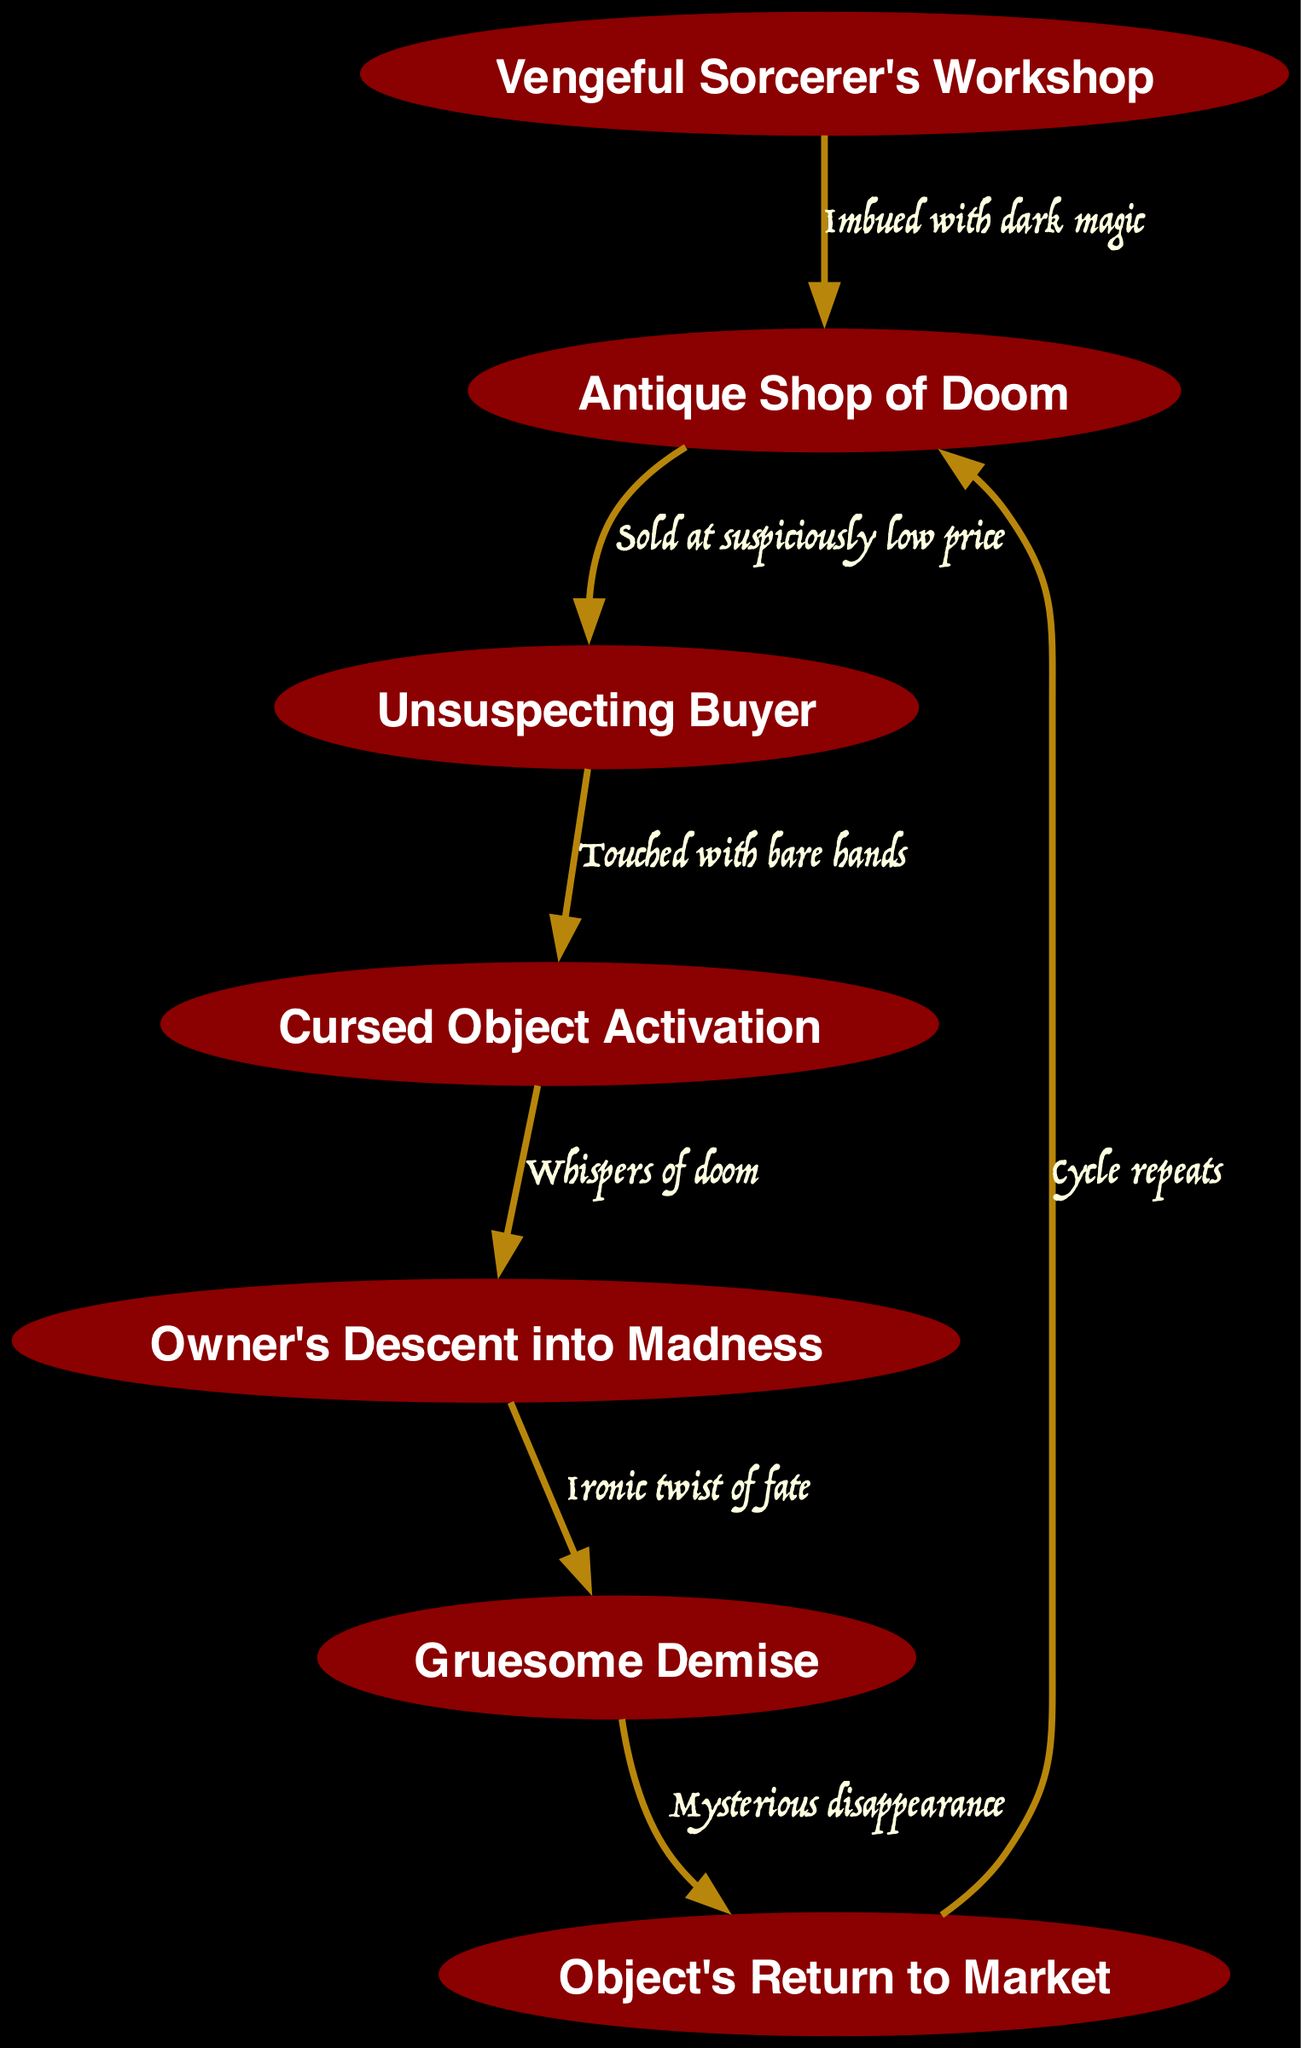What is the first node in the diagram? The first node listed in the data is "Vengeful Sorcerer's Workshop". This represents the origin of the cursed object, indicating where dark magic is applied prior to entering the market.
Answer: Vengeful Sorcerer's Workshop How many nodes are in the diagram? The diagram comprises a total of seven nodes, each representing a distinct stage in the life cycle of the cursed object, from its creation to its resale.
Answer: 7 What edge connects the Antique Shop of Doom to the Unsuspecting Buyer? The edge connecting these two nodes is labeled "Sold at suspiciously low price". This indicates that the cursed object is sold at a price that raises suspicion.
Answer: Sold at suspiciously low price What happens when the owner touches the cursed object? Upon touching the object, it activates, initiating a series of ominous effects as indicated by the edge label "Touched with bare hands", leading to the owner's subsequent madness.
Answer: Cursed Object Activation What indicates the owner's fate once they descend into madness? The transition from the owner's descent into madness to their demise is marked by an "Ironic twist of fate". This implies that their end is tied to the very madness inflicted by the cursed object.
Answer: Ironic twist of fate What is the final outcome of the cursed object after the owner's demise? After the owner's gruesome demise, the object is marked by "Mysterious disappearance", suggesting it vanishes or reemerges to perpetuate the cycle of doom, eventually ending up back in the Antique Shop of Doom.
Answer: Mysterious disappearance What connects the Owner's Descent into Madness to the Gruesome Demise? The connection between these two nodes is illustrated with the edge labeled "Ironic twist of fate", indicating that the owner's madness directly leads to their gruesome end, often in a darkly humorous way.
Answer: Ironic twist of fate What is the relationship between the last node and the Antique Shop of Doom? The last node, indicating the object's return to the market, is connected to the Antique Shop of Doom with the label "Cycle repeats", revealing that the cursed object inevitably returns to where it began to find a new victim.
Answer: Cycle repeats 